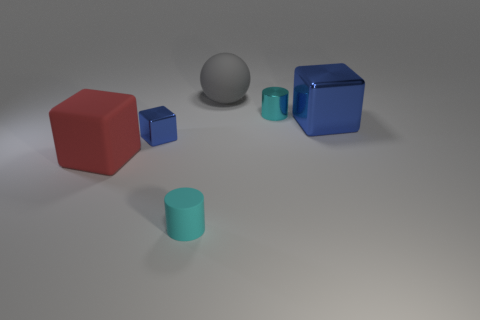Do the rubber cylinder and the red block have the same size?
Your answer should be very brief. No. How many other objects are the same size as the gray matte object?
Provide a succinct answer. 2. What number of things are either small cyan objects right of the big matte ball or large things right of the red cube?
Your response must be concise. 3. What is the shape of the cyan object that is the same size as the metal cylinder?
Provide a succinct answer. Cylinder. There is a gray ball that is the same material as the big red thing; what size is it?
Offer a terse response. Large. Is the big red thing the same shape as the large gray rubber thing?
Give a very brief answer. No. What is the color of the shiny thing that is the same size as the red rubber object?
Give a very brief answer. Blue. What size is the cyan shiny thing that is the same shape as the tiny cyan rubber object?
Your answer should be compact. Small. What shape is the blue object in front of the big metallic thing?
Make the answer very short. Cube. Do the tiny blue metal thing and the tiny cyan thing right of the gray sphere have the same shape?
Ensure brevity in your answer.  No. 